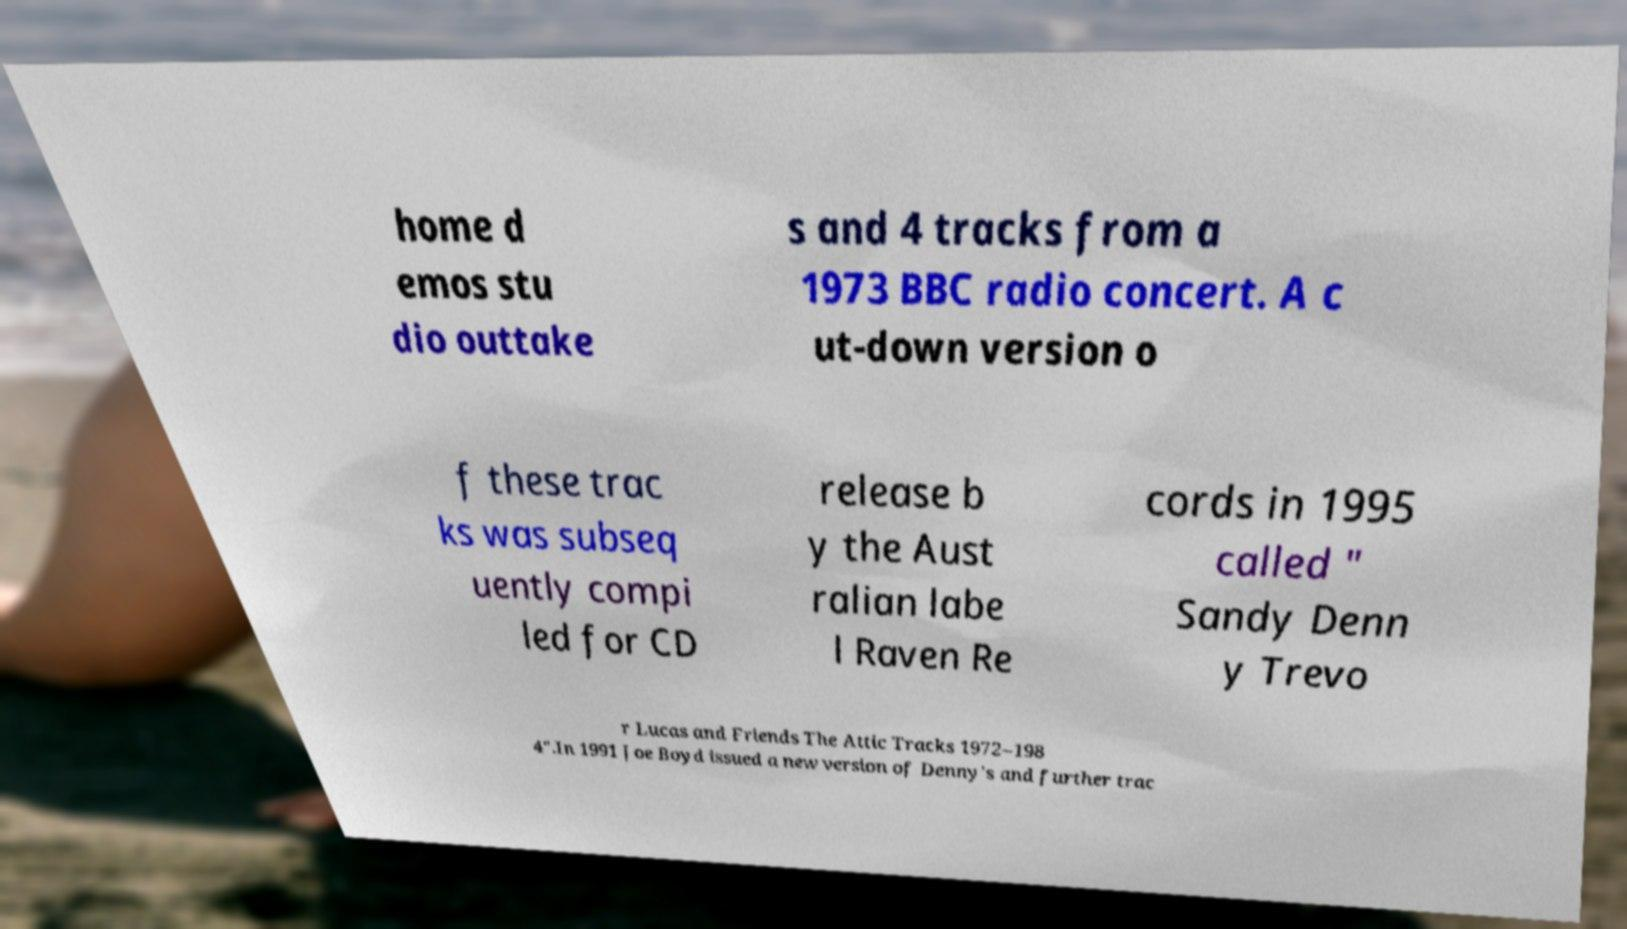There's text embedded in this image that I need extracted. Can you transcribe it verbatim? home d emos stu dio outtake s and 4 tracks from a 1973 BBC radio concert. A c ut-down version o f these trac ks was subseq uently compi led for CD release b y the Aust ralian labe l Raven Re cords in 1995 called " Sandy Denn y Trevo r Lucas and Friends The Attic Tracks 1972–198 4".In 1991 Joe Boyd issued a new version of Denny's and further trac 